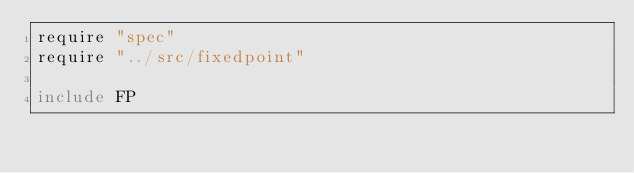Convert code to text. <code><loc_0><loc_0><loc_500><loc_500><_Crystal_>require "spec"
require "../src/fixedpoint"

include FP
</code> 